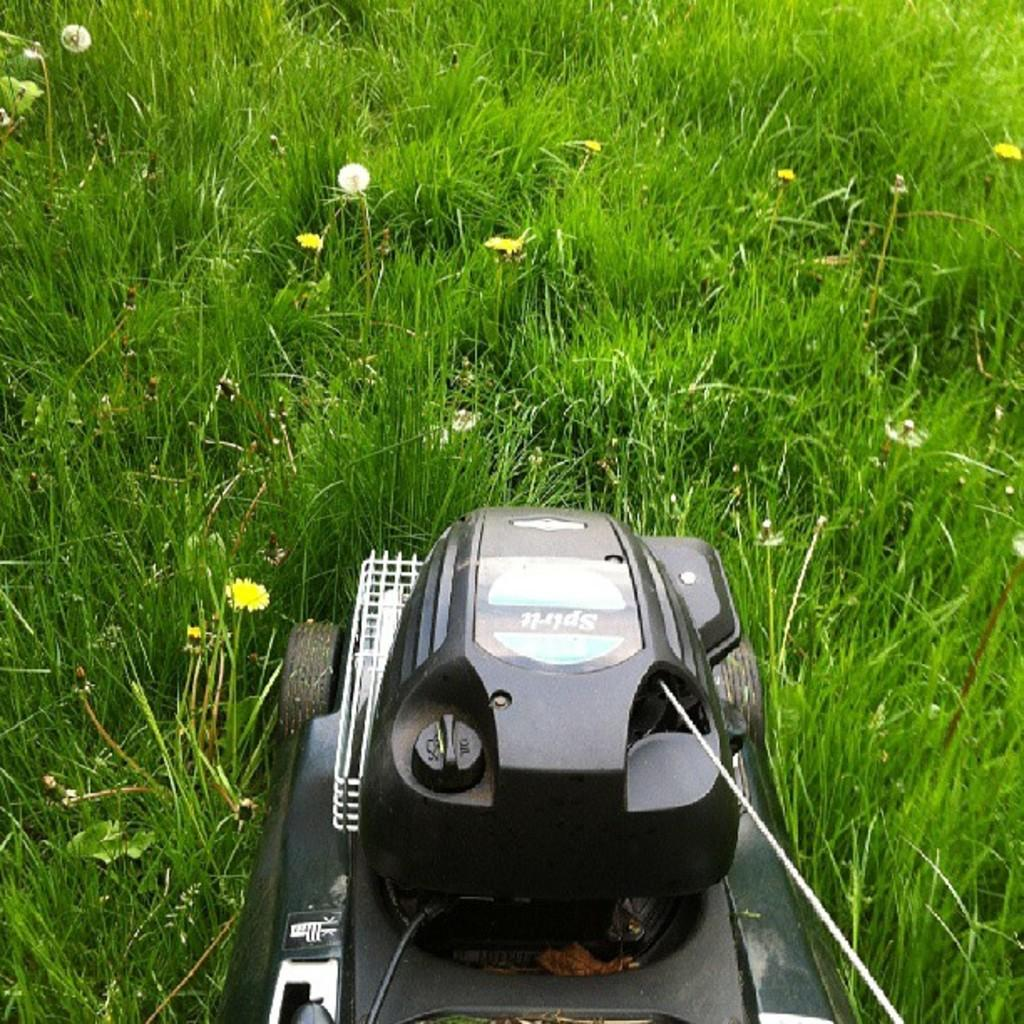What type of vegetation is present in the image? There is grass in the image. What object is located at the bottom of the image? There is a lawn mower at the bottom of the image. What type of brass instrument can be seen in the image? There is no brass instrument present in the image; it features grass and a lawn mower. 